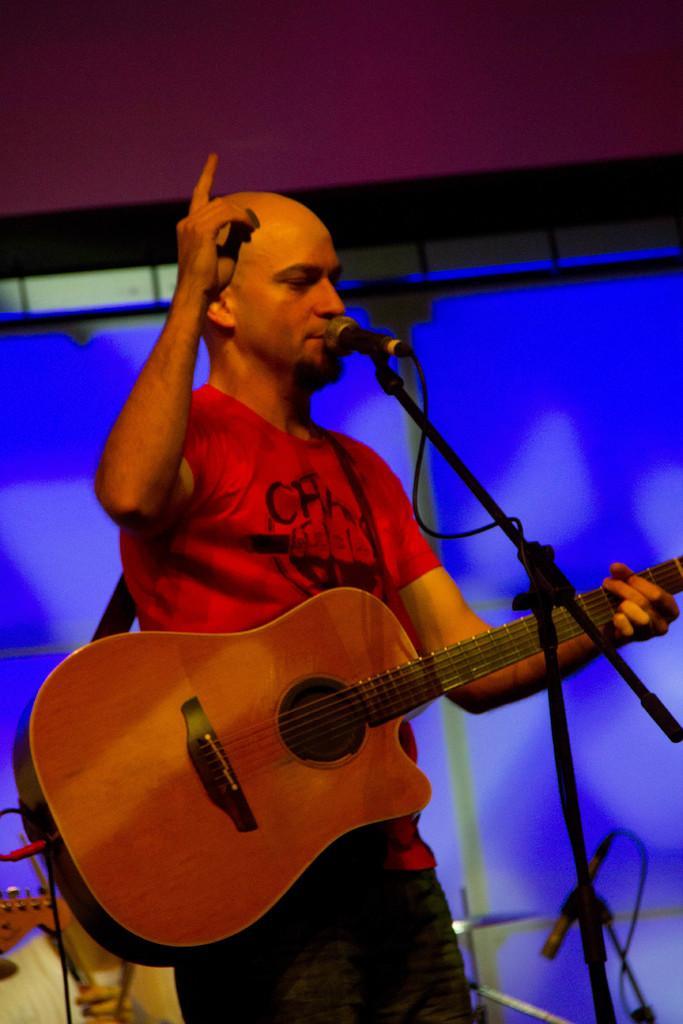Describe this image in one or two sentences. There is a man standing at the center. He is holding a guitar in his hand and he is speaking on a microphone. 